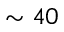Convert formula to latex. <formula><loc_0><loc_0><loc_500><loc_500>\sim 4 0</formula> 